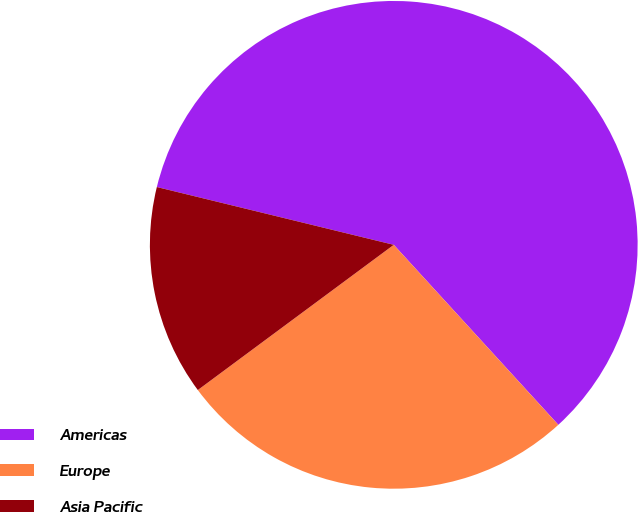Convert chart to OTSL. <chart><loc_0><loc_0><loc_500><loc_500><pie_chart><fcel>Americas<fcel>Europe<fcel>Asia Pacific<nl><fcel>59.41%<fcel>26.64%<fcel>13.96%<nl></chart> 